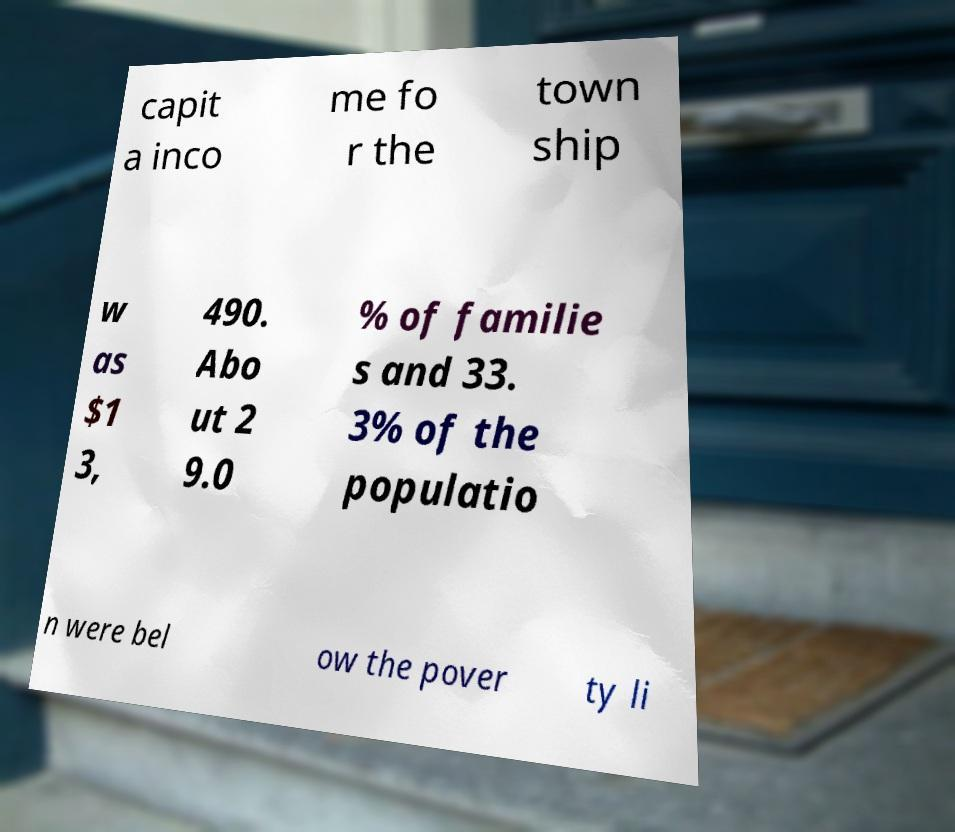Can you accurately transcribe the text from the provided image for me? capit a inco me fo r the town ship w as $1 3, 490. Abo ut 2 9.0 % of familie s and 33. 3% of the populatio n were bel ow the pover ty li 